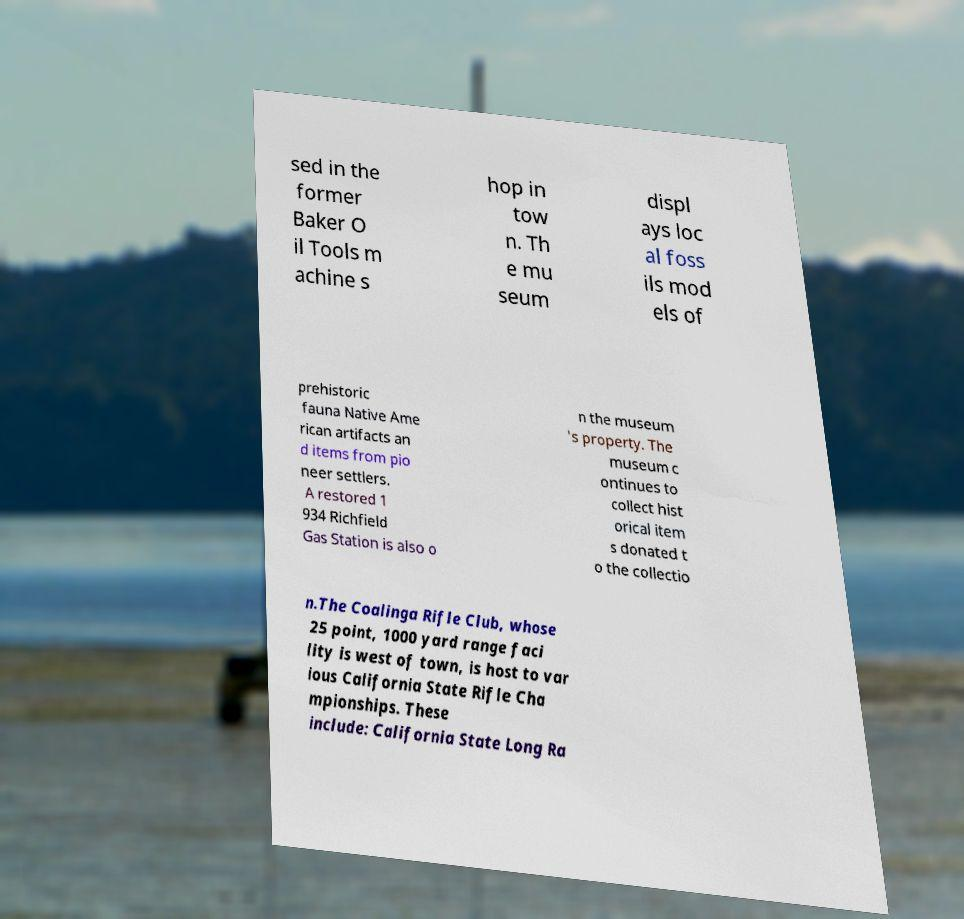I need the written content from this picture converted into text. Can you do that? sed in the former Baker O il Tools m achine s hop in tow n. Th e mu seum displ ays loc al foss ils mod els of prehistoric fauna Native Ame rican artifacts an d items from pio neer settlers. A restored 1 934 Richfield Gas Station is also o n the museum 's property. The museum c ontinues to collect hist orical item s donated t o the collectio n.The Coalinga Rifle Club, whose 25 point, 1000 yard range faci lity is west of town, is host to var ious California State Rifle Cha mpionships. These include: California State Long Ra 